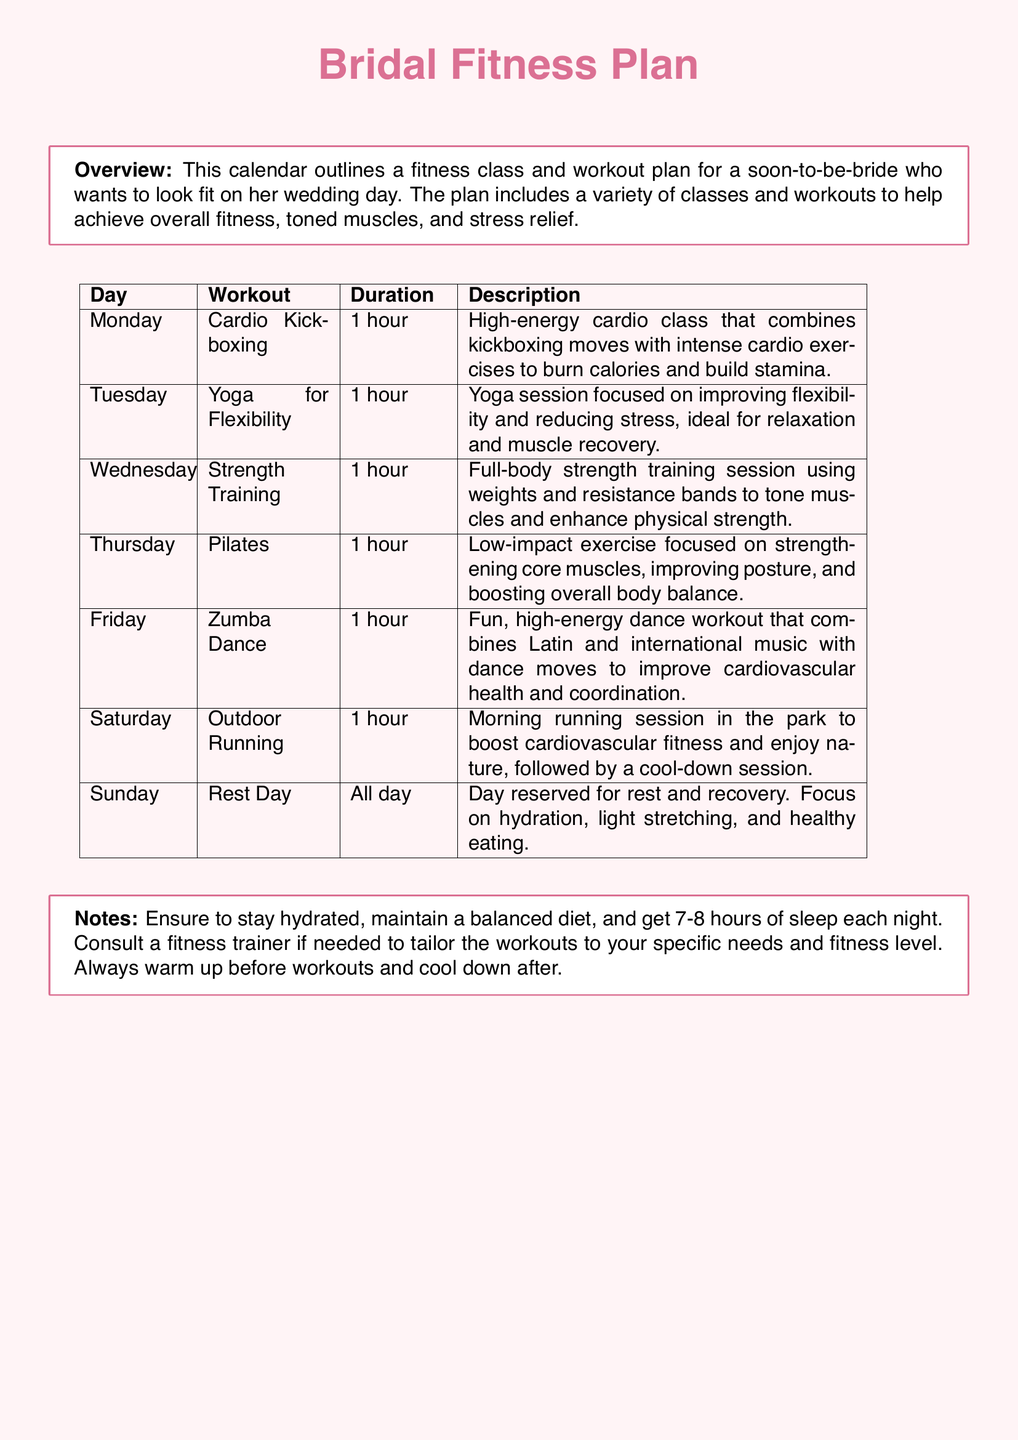What is the first workout listed? The first workout in the calendar is Cardio Kickboxing, which is specified for Monday.
Answer: Cardio Kickboxing How long is the Pilates class? The duration of the Pilates class listed on Thursday is 1 hour.
Answer: 1 hour Which day features a rest day? The document specifies Sunday as the day reserved for rest and recovery.
Answer: Sunday What type of workout is scheduled for Wednesday? On Wednesday, a Strength Training session is scheduled.
Answer: Strength Training How many different types of workouts are listed in the calendar? There are a total of 6 different workouts specified in the document from Monday to Saturday, plus the rest day.
Answer: 6 What should you focus on during the rest day? The notes indicate the focus should be on hydration, light stretching, and healthy eating during the rest day.
Answer: Hydration, light stretching, and healthy eating What is the main objective of the Bridal Fitness Plan? The document states the objective is to achieve overall fitness, toned muscles, and stress relief for the bride.
Answer: Overall fitness, toned muscles, and stress relief Which class combines music and dance moves? The Zumba Dance class on Friday combines Latin and international music with dance moves.
Answer: Zumba Dance What equipment is used in Strength Training? The Strength Training session incorporates weights and resistance bands as mentioned in the description.
Answer: Weights and resistance bands 